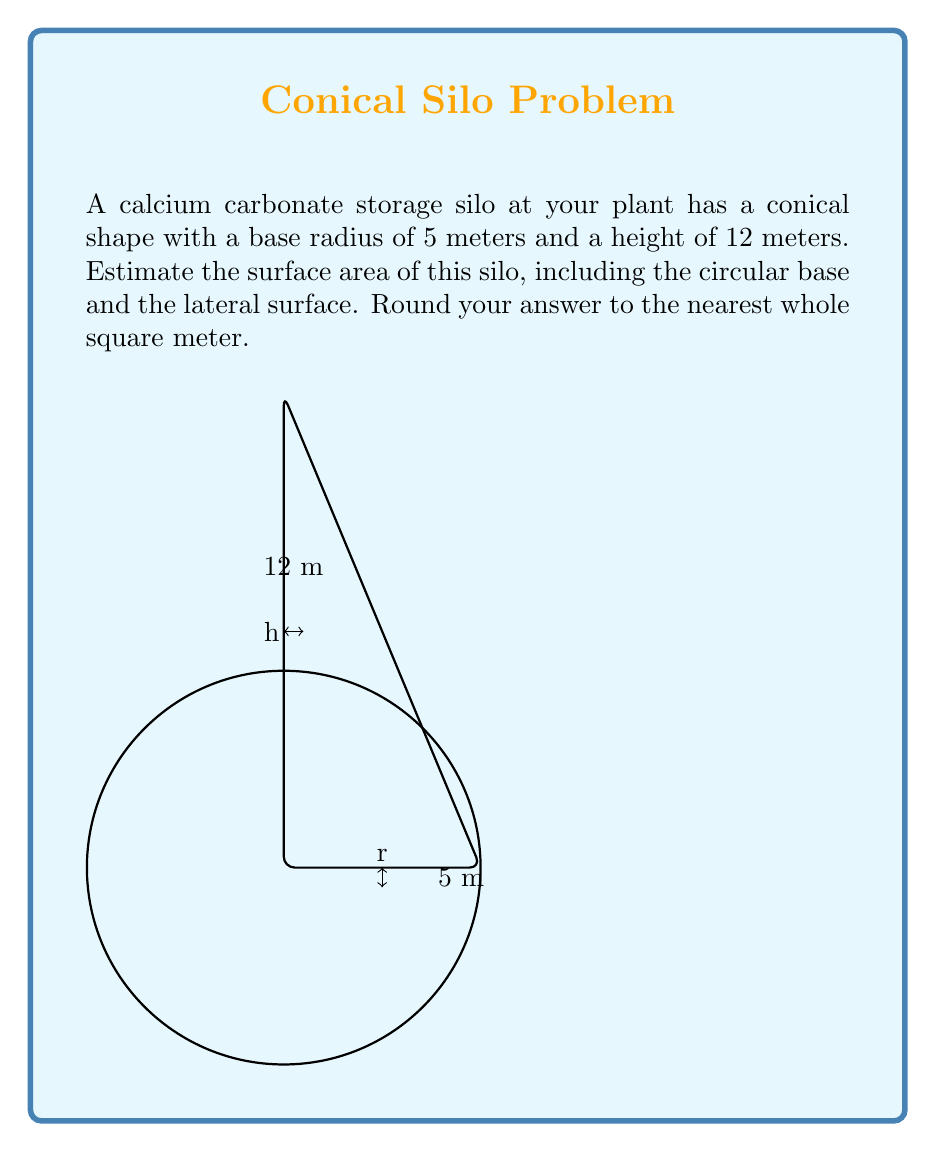Give your solution to this math problem. Let's approach this step-by-step using polar coordinates:

1) The surface area of a cone consists of two parts: the circular base and the lateral surface.

2) For the circular base:
   Area = $\pi r^2 = \pi (5\text{ m})^2 = 25\pi\text{ m}^2$

3) For the lateral surface, we need to find the slant height $s$:
   $s = \sqrt{r^2 + h^2} = \sqrt{5^2 + 12^2} = \sqrt{25 + 144} = \sqrt{169} = 13\text{ m}$

4) The lateral surface area can be calculated using the formula:
   $A_{\text{lateral}} = \pi rs = \pi(5\text{ m})(13\text{ m}) = 65\pi\text{ m}^2$

5) Total surface area:
   $A_{\text{total}} = A_{\text{base}} + A_{\text{lateral}} = 25\pi\text{ m}^2 + 65\pi\text{ m}^2 = 90\pi\text{ m}^2$

6) Calculate the numerical value:
   $A_{\text{total}} = 90\pi \approx 282.74\text{ m}^2$

7) Rounding to the nearest whole square meter:
   $A_{\text{total}} \approx 283\text{ m}^2$
Answer: $283\text{ m}^2$ 